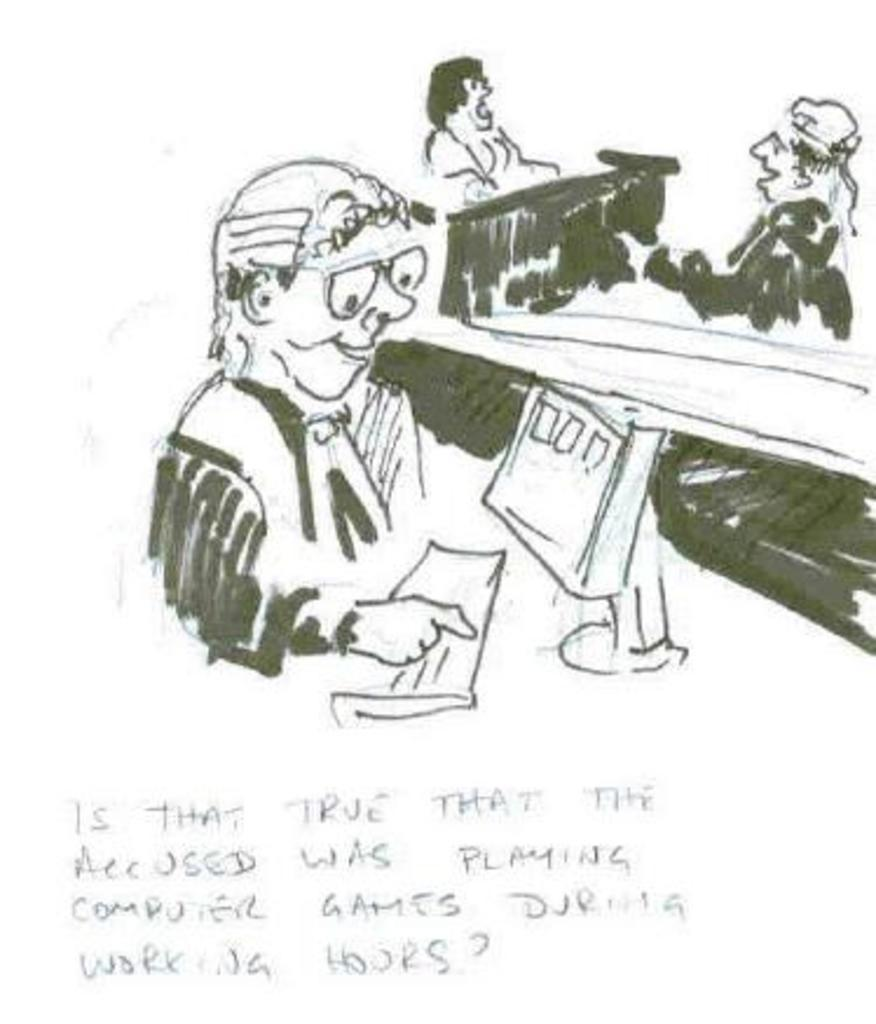What is depicted in the drawing in the image? There is a drawing of three persons in the image. What electronic device is present in the image? There is a computer in the image. What is used for typing on the computer in the image? There is a keyboard in the image. What can be found on the image besides the drawing and electronic devices? There are words on the image. Where is the science lab located in the image? There is no science lab present in the image. Can you tell me how many people are swimming in the image? There is no swimming or pool depicted in the image. 